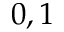<formula> <loc_0><loc_0><loc_500><loc_500>0 , 1</formula> 